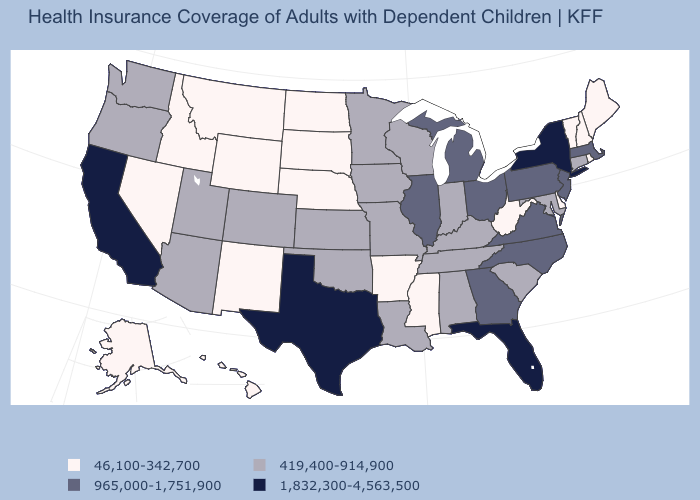Does Connecticut have a higher value than Wyoming?
Quick response, please. Yes. Does the first symbol in the legend represent the smallest category?
Concise answer only. Yes. What is the value of West Virginia?
Answer briefly. 46,100-342,700. What is the value of Connecticut?
Answer briefly. 419,400-914,900. Does Nebraska have a higher value than Louisiana?
Concise answer only. No. How many symbols are there in the legend?
Give a very brief answer. 4. Which states have the highest value in the USA?
Short answer required. California, Florida, New York, Texas. Which states have the lowest value in the USA?
Short answer required. Alaska, Arkansas, Delaware, Hawaii, Idaho, Maine, Mississippi, Montana, Nebraska, Nevada, New Hampshire, New Mexico, North Dakota, Rhode Island, South Dakota, Vermont, West Virginia, Wyoming. Which states have the lowest value in the USA?
Answer briefly. Alaska, Arkansas, Delaware, Hawaii, Idaho, Maine, Mississippi, Montana, Nebraska, Nevada, New Hampshire, New Mexico, North Dakota, Rhode Island, South Dakota, Vermont, West Virginia, Wyoming. Which states have the lowest value in the USA?
Answer briefly. Alaska, Arkansas, Delaware, Hawaii, Idaho, Maine, Mississippi, Montana, Nebraska, Nevada, New Hampshire, New Mexico, North Dakota, Rhode Island, South Dakota, Vermont, West Virginia, Wyoming. How many symbols are there in the legend?
Quick response, please. 4. Does Utah have the lowest value in the West?
Answer briefly. No. Name the states that have a value in the range 1,832,300-4,563,500?
Concise answer only. California, Florida, New York, Texas. Among the states that border Washington , does Oregon have the lowest value?
Quick response, please. No. 